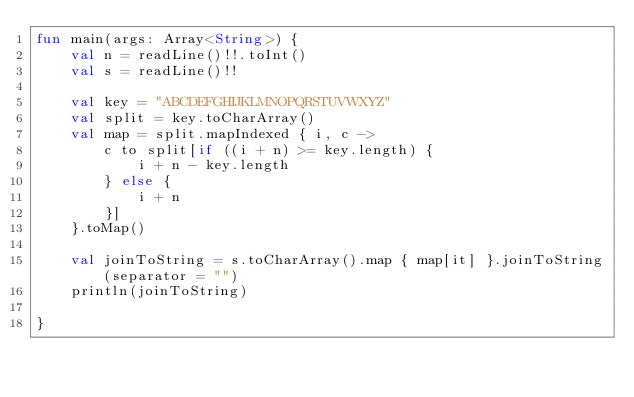<code> <loc_0><loc_0><loc_500><loc_500><_Kotlin_>fun main(args: Array<String>) {
    val n = readLine()!!.toInt()
    val s = readLine()!!

    val key = "ABCDEFGHIJKLMNOPQRSTUVWXYZ"
    val split = key.toCharArray()
    val map = split.mapIndexed { i, c ->
        c to split[if ((i + n) >= key.length) {
            i + n - key.length
        } else {
            i + n
        }]
    }.toMap()

    val joinToString = s.toCharArray().map { map[it] }.joinToString(separator = "")
    println(joinToString)

}
</code> 